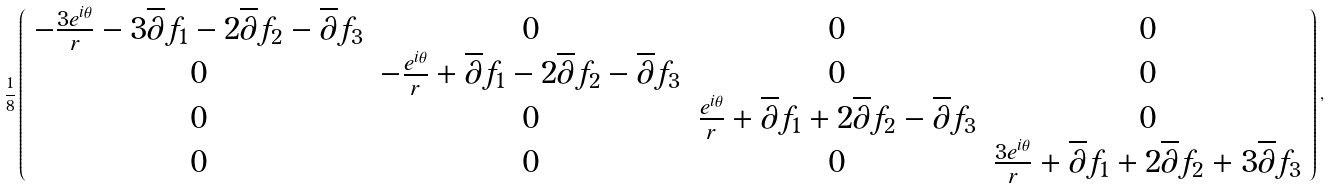<formula> <loc_0><loc_0><loc_500><loc_500>\frac { 1 } { 8 } \left ( \begin{array} { c c c c } - \frac { 3 e ^ { i \theta } } { r } - 3 \overline { \partial } f _ { 1 } - 2 \overline { \partial } f _ { 2 } - \overline { \partial } f _ { 3 } & 0 & 0 & 0 \\ 0 & - \frac { e ^ { i \theta } } { r } + \overline { \partial } f _ { 1 } - 2 \overline { \partial } f _ { 2 } - \overline { \partial } f _ { 3 } & 0 & 0 \\ 0 & 0 & \frac { e ^ { i \theta } } { r } + \overline { \partial } f _ { 1 } + 2 \overline { \partial } f _ { 2 } - \overline { \partial } f _ { 3 } & 0 \\ 0 & 0 & 0 & \frac { 3 e ^ { i \theta } } { r } + \overline { \partial } f _ { 1 } + 2 \overline { \partial } f _ { 2 } + 3 \overline { \partial } f _ { 3 } \end{array} \right ) ,</formula> 